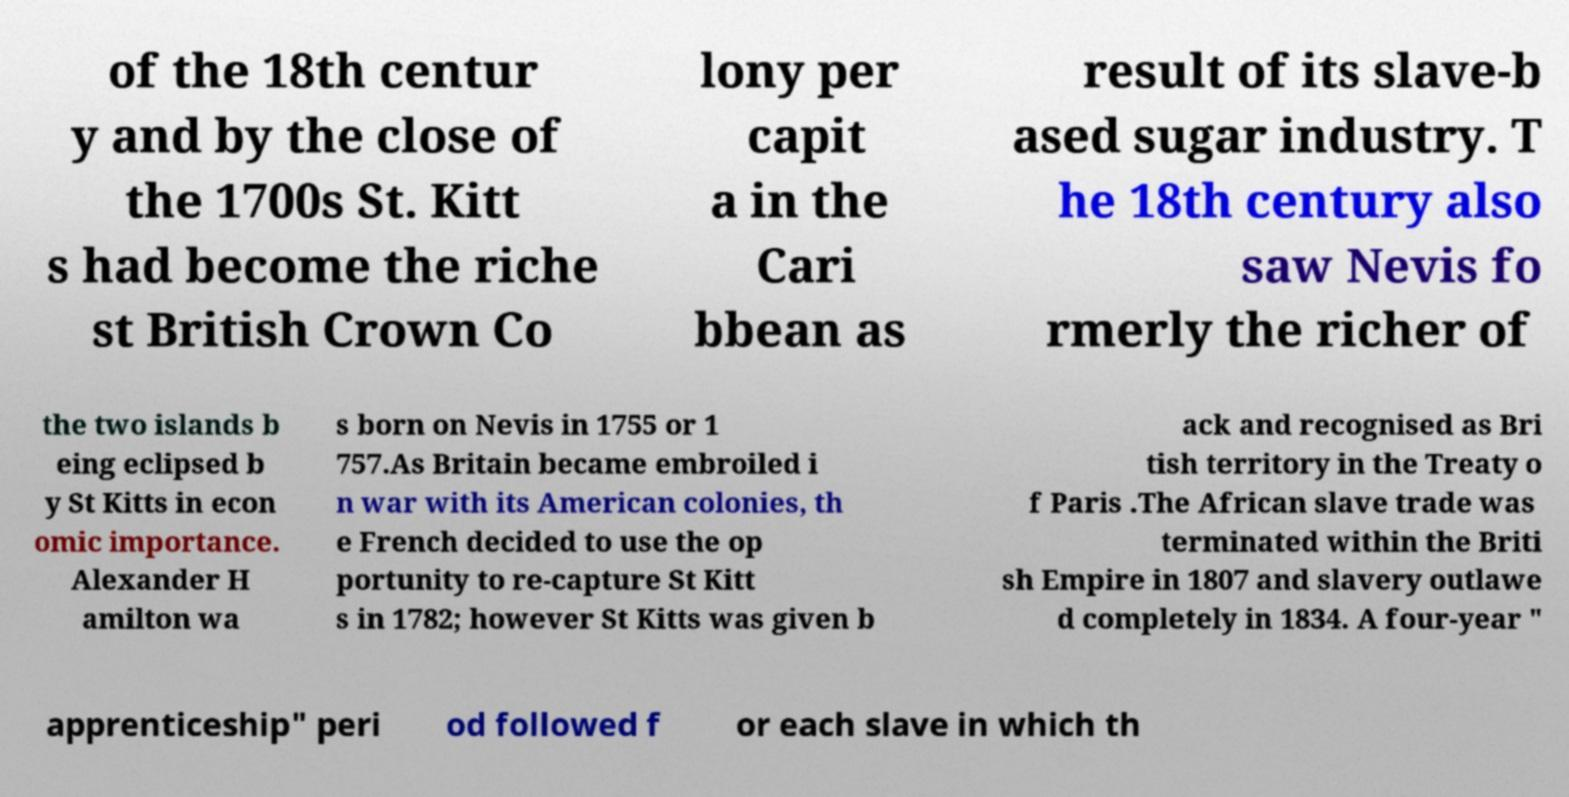For documentation purposes, I need the text within this image transcribed. Could you provide that? of the 18th centur y and by the close of the 1700s St. Kitt s had become the riche st British Crown Co lony per capit a in the Cari bbean as result of its slave-b ased sugar industry. T he 18th century also saw Nevis fo rmerly the richer of the two islands b eing eclipsed b y St Kitts in econ omic importance. Alexander H amilton wa s born on Nevis in 1755 or 1 757.As Britain became embroiled i n war with its American colonies, th e French decided to use the op portunity to re-capture St Kitt s in 1782; however St Kitts was given b ack and recognised as Bri tish territory in the Treaty o f Paris .The African slave trade was terminated within the Briti sh Empire in 1807 and slavery outlawe d completely in 1834. A four-year " apprenticeship" peri od followed f or each slave in which th 